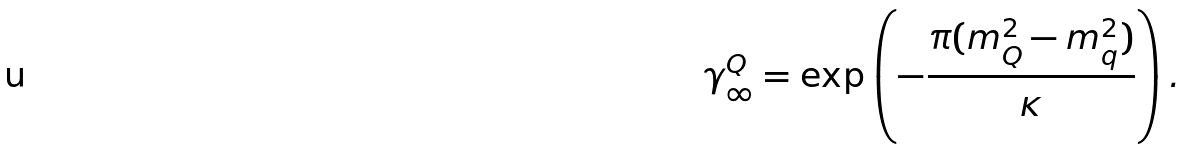Convert formula to latex. <formula><loc_0><loc_0><loc_500><loc_500>\gamma ^ { Q } _ { \infty } = \exp \left ( - \frac { \pi ( m _ { Q } ^ { 2 } - m _ { q } ^ { 2 } ) } { \kappa } \right ) .</formula> 